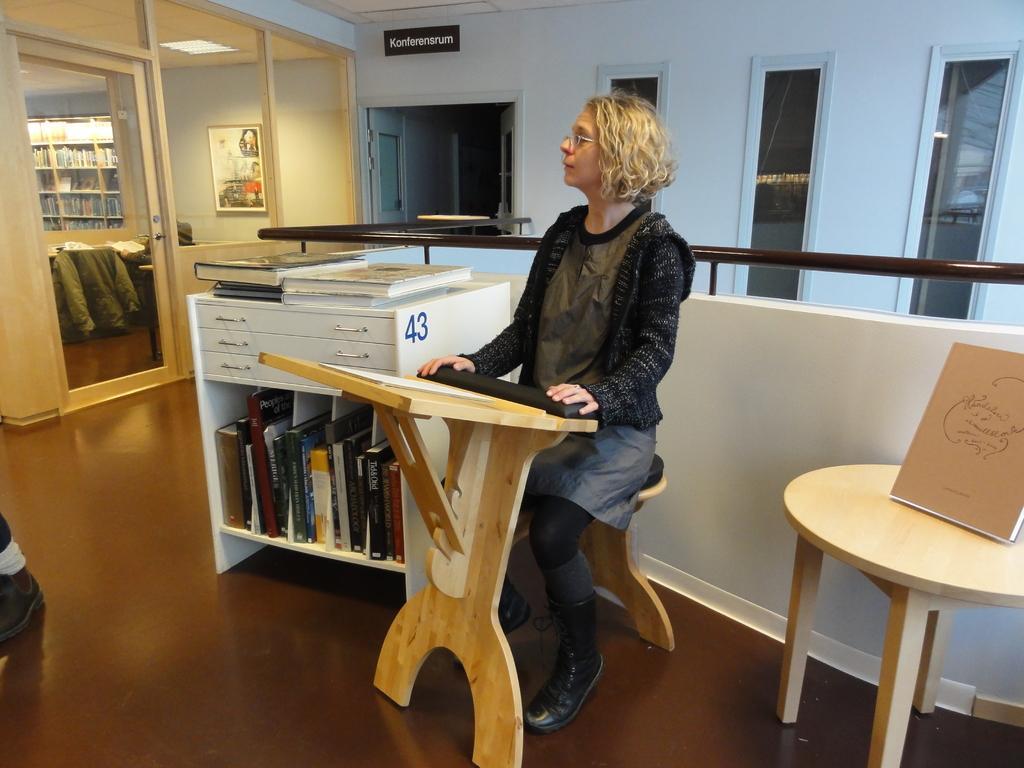In one or two sentences, can you explain what this image depicts? In this image I see a woman who is sitting on the stool and there is a table in front, I also see there is another table over here. In the background I see a cupboard few books in it and on it and a door and the widows. 